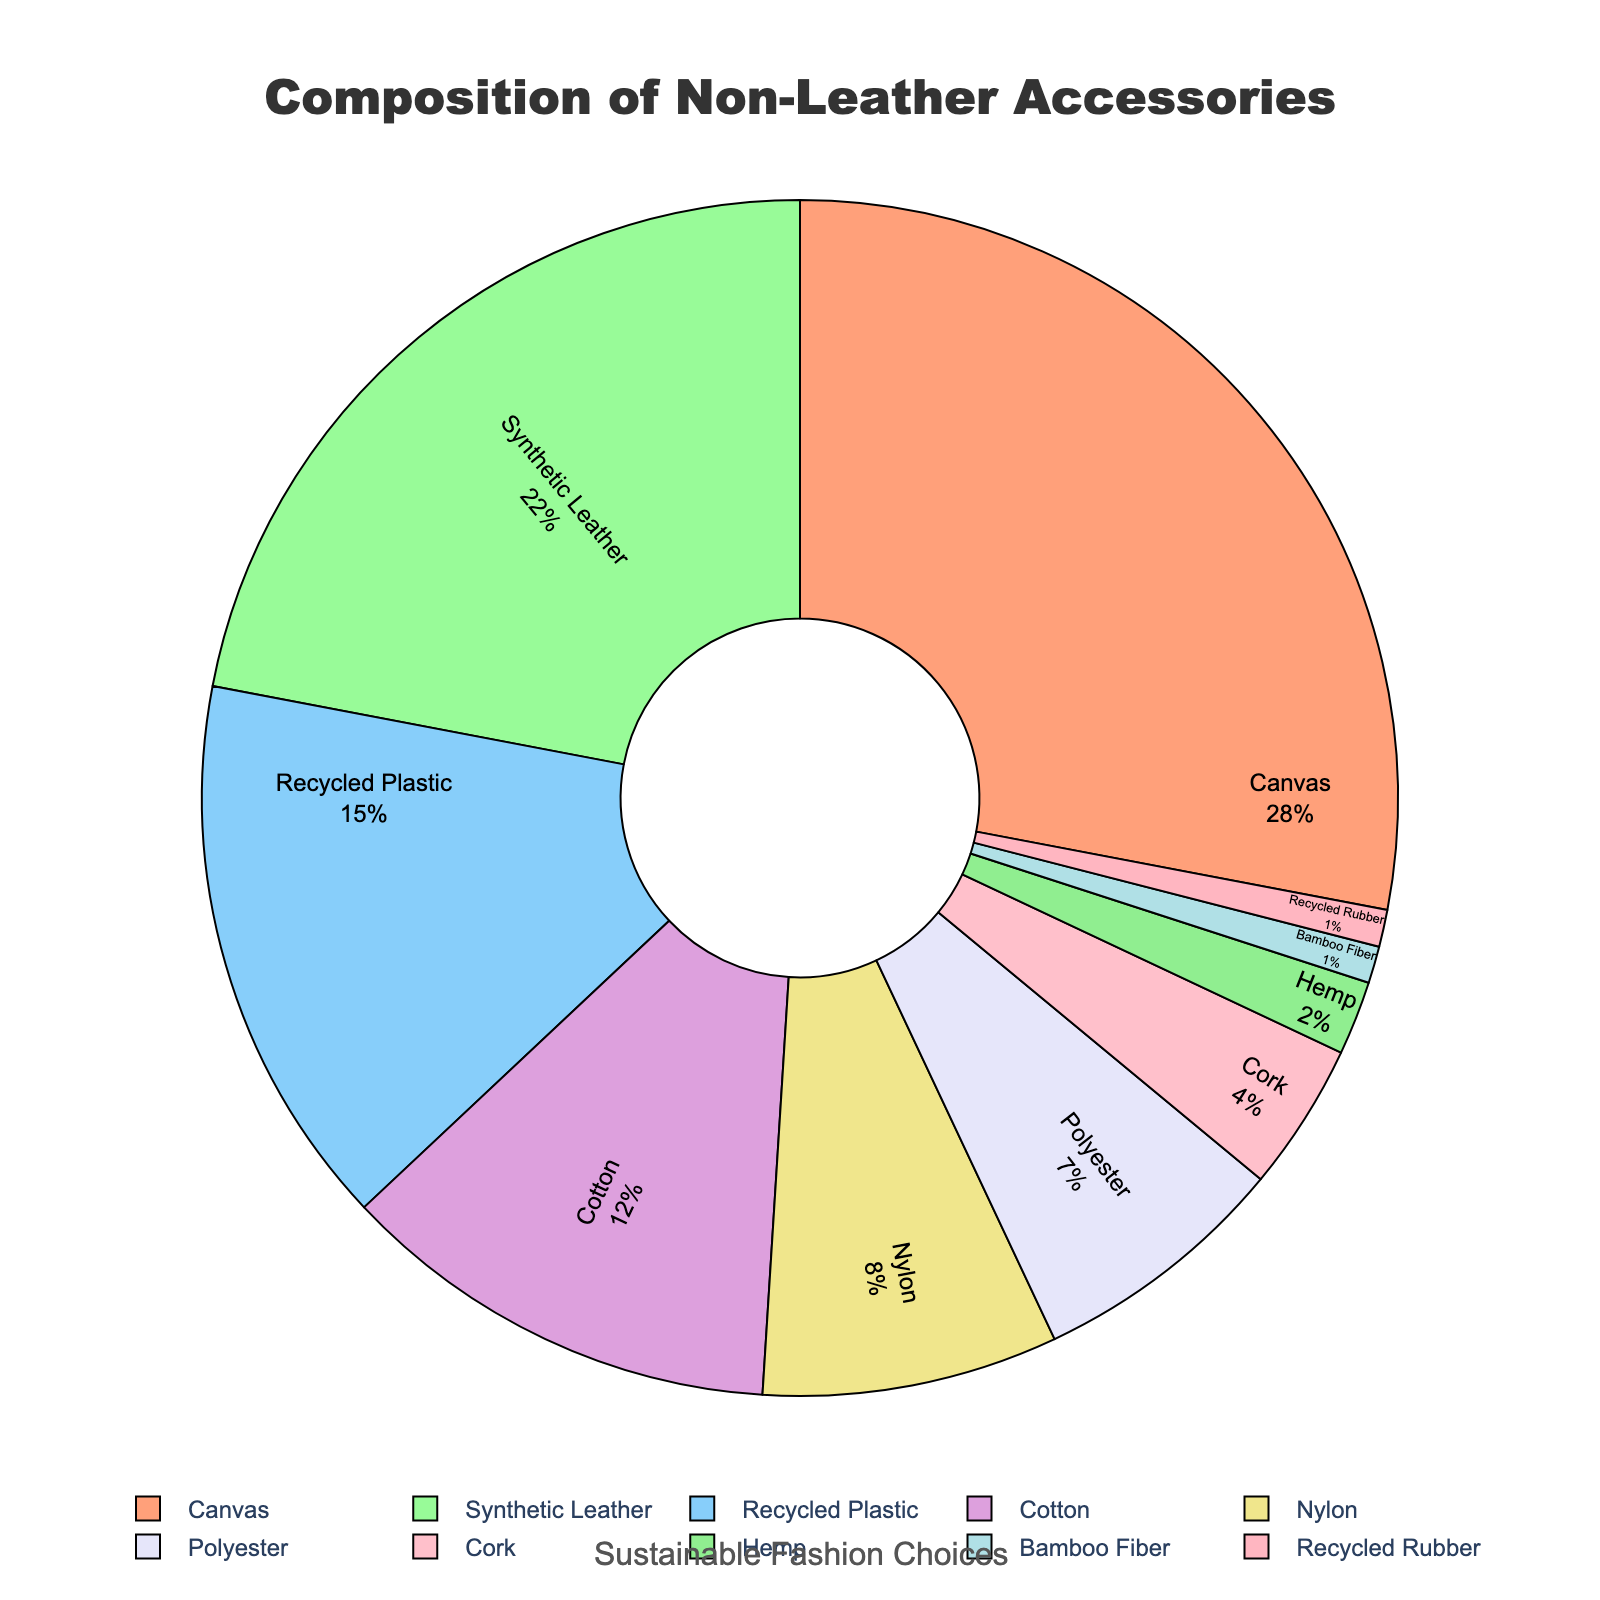Which material has the highest percentage in non-leather accessories? By visually inspecting the pie chart, the largest segment is for Canvas.
Answer: Canvas Which materials together make up less than 10% of non-leather accessories? Summing the percentages of materials with less than 10% individually: Hemp (2%) + Bamboo Fiber (1%) + Recycled Rubber (1%) + Cork (4%) totals 8%, which is less than 10%.
Answer: Hemp, Bamboo Fiber, Recycled Rubber, and Cork What is the difference in percentage between the most and least used materials? The most used material is Canvas (28%), and the least used are Bamboo Fiber and Recycled Rubber, both at (1%). The difference is 28% - 1% = 27%.
Answer: 27% Which material closest follows Canvas in composition? The chart displays Synthetic Leather as the second-largest section after Canvas.
Answer: Synthetic Leather What percentage of the materials are sustainable options like Recycled Plastic and Cork? Adding the percentages of Recycled Plastic (15%) and Cork (4%): 15% + 4% = 19%.
Answer: 19% Are there more synthetic-based or natural-based materials, and by how much? Synthetic-based materials: Synthetic Leather (22%) + Recycled Plastic (15%) + Nylon (8%) + Polyester (7%) + Recycled Rubber (1%) = 53%. Natural-based materials: Canvas (28%) + Cotton (12%) + Cork (4%) + Hemp (2%) + Bamboo Fiber (1%) = 47%. Difference: 53% - 47% = 6%.
Answer: Synthetic-based by 6% Which materials have a combined percentage equal to or closest to that of Synthetic Leather? Synthetic Leather is 22%. Summing nearby values: Canvas (28%) is higher, Recycled Plastic (15%) + Cotton (12%) = 27%, which is closest but more than 22%. However, Cotton (12%) + Nylon (8%) = 20%, which is close but less than 22%. The closest sum near 22% is Cotton and Nylon combined.
Answer: Cotton and Nylon How many materials make up at least 10% of the total composition individually? The pie chart segments with at least 10% are for Canvas (28%), Synthetic Leather (22%), Recycled Plastic (15%), and Cotton (12%).
Answer: 4 materials 